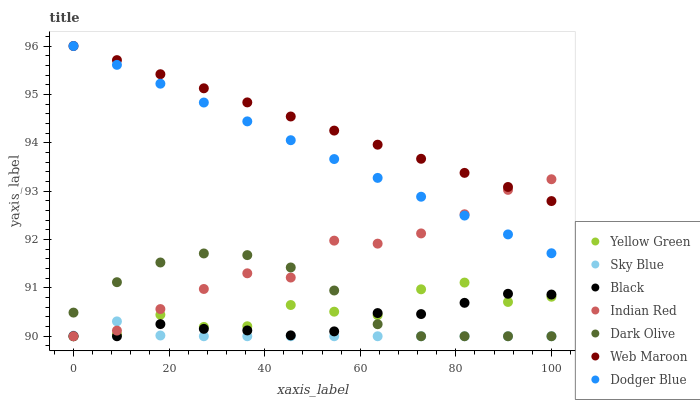Does Sky Blue have the minimum area under the curve?
Answer yes or no. Yes. Does Web Maroon have the maximum area under the curve?
Answer yes or no. Yes. Does Dark Olive have the minimum area under the curve?
Answer yes or no. No. Does Dark Olive have the maximum area under the curve?
Answer yes or no. No. Is Dodger Blue the smoothest?
Answer yes or no. Yes. Is Yellow Green the roughest?
Answer yes or no. Yes. Is Dark Olive the smoothest?
Answer yes or no. No. Is Dark Olive the roughest?
Answer yes or no. No. Does Yellow Green have the lowest value?
Answer yes or no. Yes. Does Web Maroon have the lowest value?
Answer yes or no. No. Does Dodger Blue have the highest value?
Answer yes or no. Yes. Does Dark Olive have the highest value?
Answer yes or no. No. Is Dark Olive less than Dodger Blue?
Answer yes or no. Yes. Is Web Maroon greater than Yellow Green?
Answer yes or no. Yes. Does Sky Blue intersect Yellow Green?
Answer yes or no. Yes. Is Sky Blue less than Yellow Green?
Answer yes or no. No. Is Sky Blue greater than Yellow Green?
Answer yes or no. No. Does Dark Olive intersect Dodger Blue?
Answer yes or no. No. 